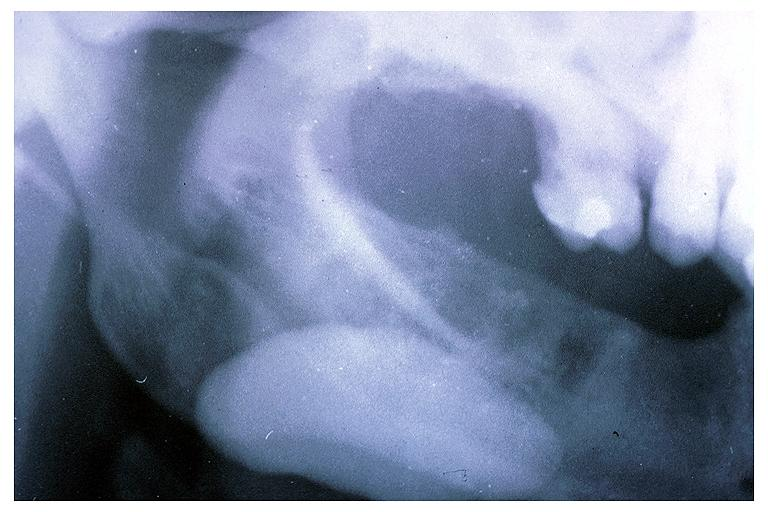what is present?
Answer the question using a single word or phrase. Oral 